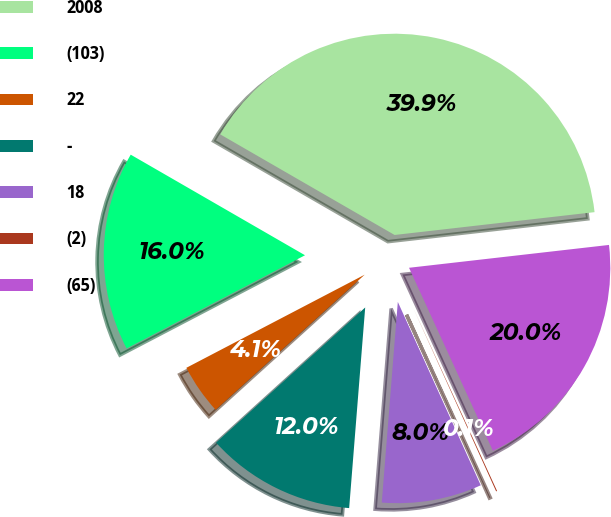Convert chart to OTSL. <chart><loc_0><loc_0><loc_500><loc_500><pie_chart><fcel>2008<fcel>(103)<fcel>22<fcel>-<fcel>18<fcel>(2)<fcel>(65)<nl><fcel>39.86%<fcel>15.99%<fcel>4.06%<fcel>12.01%<fcel>8.03%<fcel>0.08%<fcel>19.97%<nl></chart> 